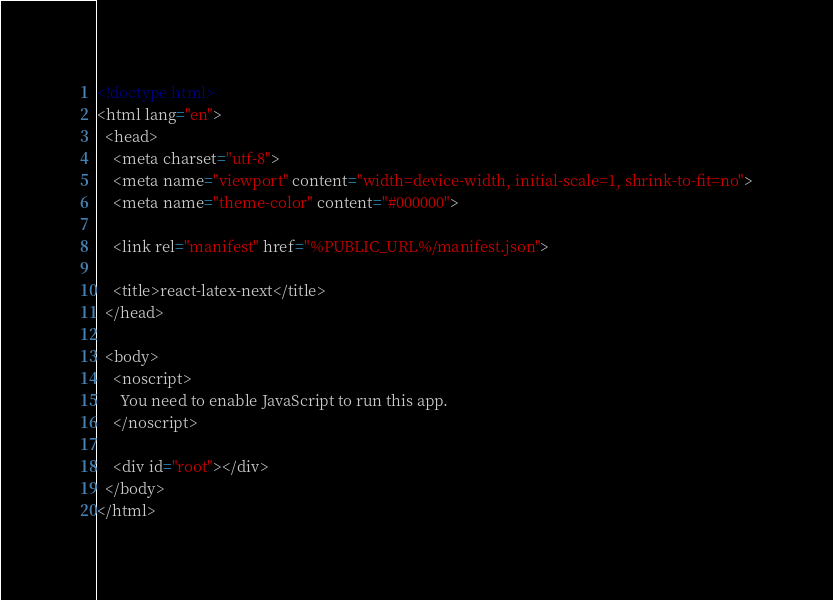Convert code to text. <code><loc_0><loc_0><loc_500><loc_500><_HTML_><!doctype html>
<html lang="en">
  <head>
    <meta charset="utf-8">
    <meta name="viewport" content="width=device-width, initial-scale=1, shrink-to-fit=no">
    <meta name="theme-color" content="#000000">

    <link rel="manifest" href="%PUBLIC_URL%/manifest.json">

    <title>react-latex-next</title>
  </head>

  <body>
    <noscript>
      You need to enable JavaScript to run this app.
    </noscript>

    <div id="root"></div>
  </body>
</html>
</code> 